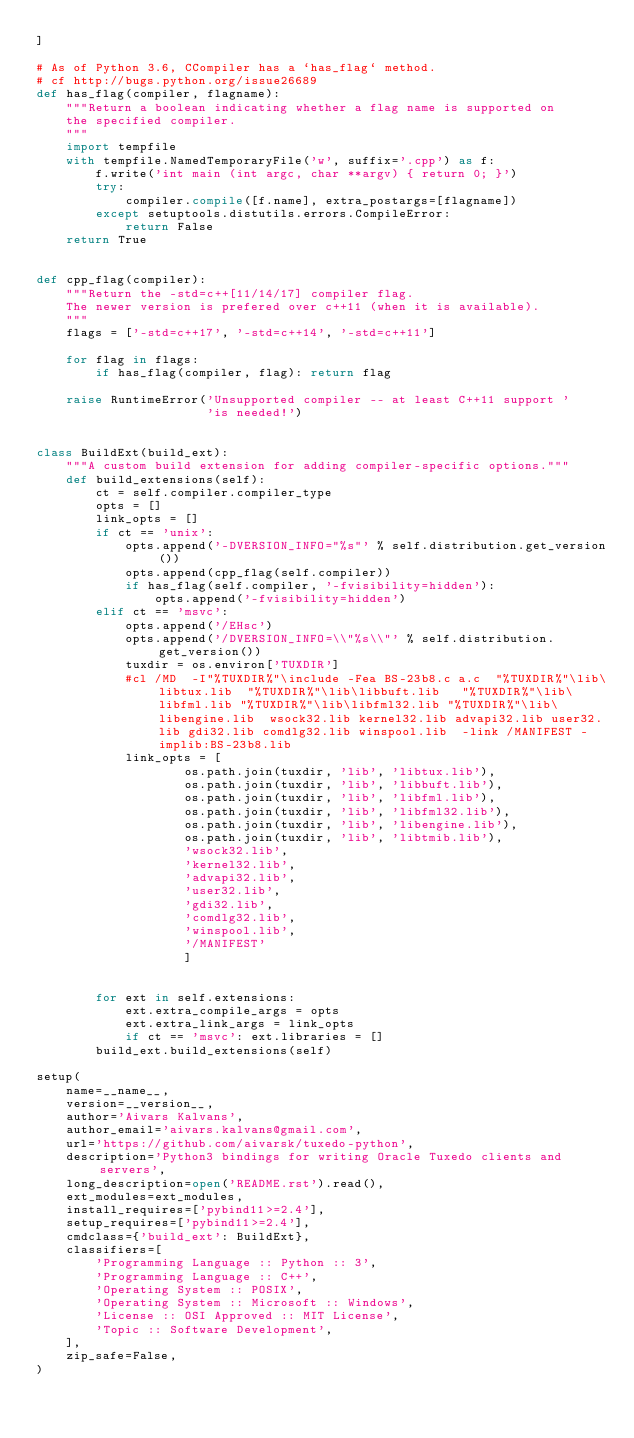<code> <loc_0><loc_0><loc_500><loc_500><_Python_>]

# As of Python 3.6, CCompiler has a `has_flag` method.
# cf http://bugs.python.org/issue26689
def has_flag(compiler, flagname):
    """Return a boolean indicating whether a flag name is supported on
    the specified compiler.
    """
    import tempfile
    with tempfile.NamedTemporaryFile('w', suffix='.cpp') as f:
        f.write('int main (int argc, char **argv) { return 0; }')
        try:
            compiler.compile([f.name], extra_postargs=[flagname])
        except setuptools.distutils.errors.CompileError:
            return False
    return True


def cpp_flag(compiler):
    """Return the -std=c++[11/14/17] compiler flag.
    The newer version is prefered over c++11 (when it is available).
    """
    flags = ['-std=c++17', '-std=c++14', '-std=c++11']

    for flag in flags:
        if has_flag(compiler, flag): return flag

    raise RuntimeError('Unsupported compiler -- at least C++11 support '
                       'is needed!')


class BuildExt(build_ext):
    """A custom build extension for adding compiler-specific options."""
    def build_extensions(self):
        ct = self.compiler.compiler_type
        opts = []
        link_opts = []
        if ct == 'unix':
            opts.append('-DVERSION_INFO="%s"' % self.distribution.get_version())
            opts.append(cpp_flag(self.compiler))
            if has_flag(self.compiler, '-fvisibility=hidden'):
                opts.append('-fvisibility=hidden')
        elif ct == 'msvc':
            opts.append('/EHsc')
            opts.append('/DVERSION_INFO=\\"%s\\"' % self.distribution.get_version())
            tuxdir = os.environ['TUXDIR']
            #cl /MD  -I"%TUXDIR%"\include -Fea BS-23b8.c a.c  "%TUXDIR%"\lib\libtux.lib  "%TUXDIR%"\lib\libbuft.lib   "%TUXDIR%"\lib\libfml.lib "%TUXDIR%"\lib\libfml32.lib "%TUXDIR%"\lib\libengine.lib  wsock32.lib kernel32.lib advapi32.lib user32.lib gdi32.lib comdlg32.lib winspool.lib  -link /MANIFEST -implib:BS-23b8.lib
            link_opts = [
                    os.path.join(tuxdir, 'lib', 'libtux.lib'),
                    os.path.join(tuxdir, 'lib', 'libbuft.lib'),
                    os.path.join(tuxdir, 'lib', 'libfml.lib'),
                    os.path.join(tuxdir, 'lib', 'libfml32.lib'),
                    os.path.join(tuxdir, 'lib', 'libengine.lib'),
                    os.path.join(tuxdir, 'lib', 'libtmib.lib'),
                    'wsock32.lib',
                    'kernel32.lib',
                    'advapi32.lib',
                    'user32.lib',
                    'gdi32.lib',
                    'comdlg32.lib',
                    'winspool.lib',
                    '/MANIFEST'
                    ]


        for ext in self.extensions:
            ext.extra_compile_args = opts
            ext.extra_link_args = link_opts
            if ct == 'msvc': ext.libraries = []
        build_ext.build_extensions(self)

setup(
    name=__name__,
    version=__version__,
    author='Aivars Kalvans',
    author_email='aivars.kalvans@gmail.com',
    url='https://github.com/aivarsk/tuxedo-python',
    description='Python3 bindings for writing Oracle Tuxedo clients and servers',
    long_description=open('README.rst').read(),
    ext_modules=ext_modules,
    install_requires=['pybind11>=2.4'],
    setup_requires=['pybind11>=2.4'],
    cmdclass={'build_ext': BuildExt},
    classifiers=[
        'Programming Language :: Python :: 3',
        'Programming Language :: C++',
        'Operating System :: POSIX',
        'Operating System :: Microsoft :: Windows',
        'License :: OSI Approved :: MIT License',
        'Topic :: Software Development',
    ],
    zip_safe=False,
)
</code> 